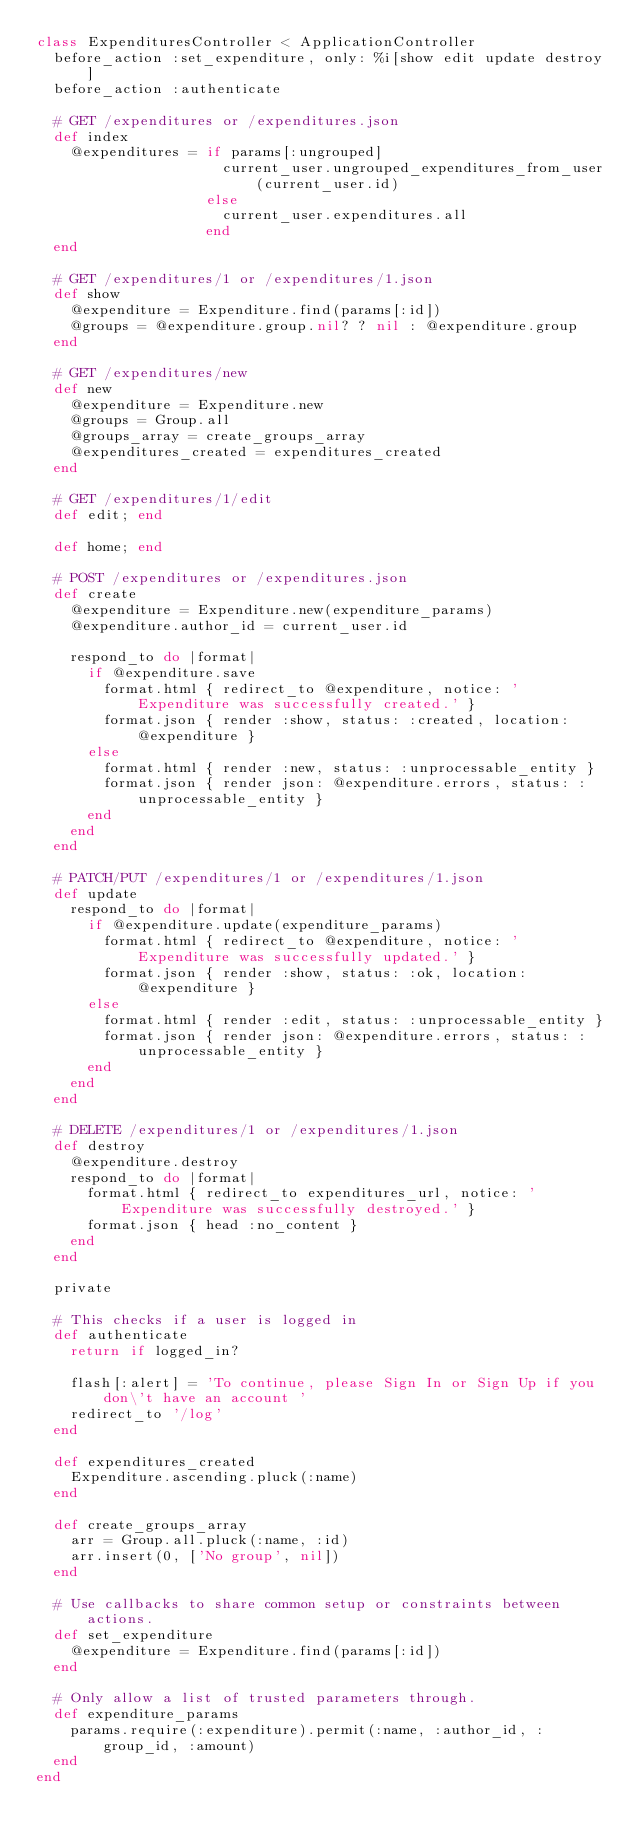<code> <loc_0><loc_0><loc_500><loc_500><_Ruby_>class ExpendituresController < ApplicationController
  before_action :set_expenditure, only: %i[show edit update destroy]
  before_action :authenticate

  # GET /expenditures or /expenditures.json
  def index
    @expenditures = if params[:ungrouped]
                      current_user.ungrouped_expenditures_from_user(current_user.id)
                    else
                      current_user.expenditures.all
                    end
  end

  # GET /expenditures/1 or /expenditures/1.json
  def show
    @expenditure = Expenditure.find(params[:id])
    @groups = @expenditure.group.nil? ? nil : @expenditure.group
  end

  # GET /expenditures/new
  def new
    @expenditure = Expenditure.new
    @groups = Group.all
    @groups_array = create_groups_array
    @expenditures_created = expenditures_created
  end

  # GET /expenditures/1/edit
  def edit; end

  def home; end

  # POST /expenditures or /expenditures.json
  def create
    @expenditure = Expenditure.new(expenditure_params)
    @expenditure.author_id = current_user.id

    respond_to do |format|
      if @expenditure.save
        format.html { redirect_to @expenditure, notice: 'Expenditure was successfully created.' }
        format.json { render :show, status: :created, location: @expenditure }
      else
        format.html { render :new, status: :unprocessable_entity }
        format.json { render json: @expenditure.errors, status: :unprocessable_entity }
      end
    end
  end

  # PATCH/PUT /expenditures/1 or /expenditures/1.json
  def update
    respond_to do |format|
      if @expenditure.update(expenditure_params)
        format.html { redirect_to @expenditure, notice: 'Expenditure was successfully updated.' }
        format.json { render :show, status: :ok, location: @expenditure }
      else
        format.html { render :edit, status: :unprocessable_entity }
        format.json { render json: @expenditure.errors, status: :unprocessable_entity }
      end
    end
  end

  # DELETE /expenditures/1 or /expenditures/1.json
  def destroy
    @expenditure.destroy
    respond_to do |format|
      format.html { redirect_to expenditures_url, notice: 'Expenditure was successfully destroyed.' }
      format.json { head :no_content }
    end
  end

  private

  # This checks if a user is logged in
  def authenticate
    return if logged_in?

    flash[:alert] = 'To continue, please Sign In or Sign Up if you don\'t have an account '
    redirect_to '/log'
  end

  def expenditures_created
    Expenditure.ascending.pluck(:name)
  end

  def create_groups_array
    arr = Group.all.pluck(:name, :id)
    arr.insert(0, ['No group', nil])
  end

  # Use callbacks to share common setup or constraints between actions.
  def set_expenditure
    @expenditure = Expenditure.find(params[:id])
  end

  # Only allow a list of trusted parameters through.
  def expenditure_params
    params.require(:expenditure).permit(:name, :author_id, :group_id, :amount)
  end
end
</code> 